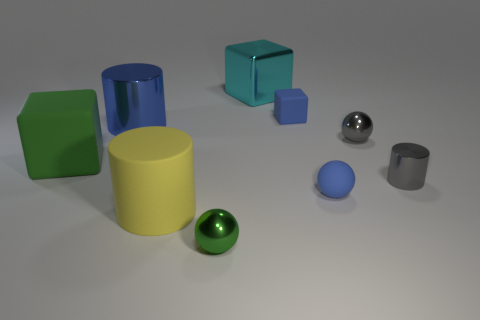What number of cyan metal cubes are the same size as the rubber sphere?
Keep it short and to the point. 0. What material is the large cyan object that is the same shape as the large green thing?
Ensure brevity in your answer.  Metal. Does the tiny matte thing that is behind the big shiny cylinder have the same color as the large cylinder behind the tiny gray cylinder?
Offer a terse response. Yes. What shape is the green object that is behind the blue matte sphere?
Offer a terse response. Cube. What is the color of the large matte cylinder?
Your answer should be very brief. Yellow. The large yellow thing that is made of the same material as the tiny cube is what shape?
Offer a very short reply. Cylinder. Do the blue block that is right of the yellow object and the matte sphere have the same size?
Your response must be concise. Yes. How many objects are tiny shiny spheres that are left of the large cyan cube or green things in front of the large yellow object?
Offer a terse response. 1. Do the matte thing that is behind the large metallic cylinder and the matte sphere have the same color?
Ensure brevity in your answer.  Yes. How many rubber things are tiny cubes or green objects?
Make the answer very short. 2. 